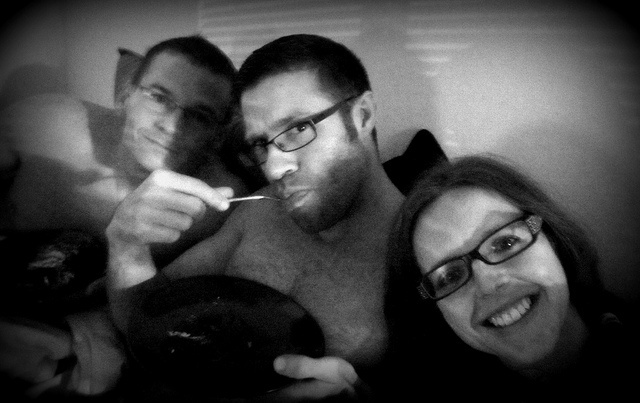Describe the objects in this image and their specific colors. I can see people in black, gray, darkgray, and lightgray tones, people in black, gray, darkgray, and lightgray tones, people in black, gray, darkgray, and lightgray tones, cake in black and gray tones, and spoon in black, gray, lightgray, and darkgray tones in this image. 